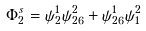<formula> <loc_0><loc_0><loc_500><loc_500>\Phi _ { 2 } ^ { s } = \psi _ { 2 } ^ { 1 } \psi _ { 2 6 } ^ { 2 } + \psi _ { 2 6 } ^ { 1 } \psi _ { 1 } ^ { 2 }</formula> 